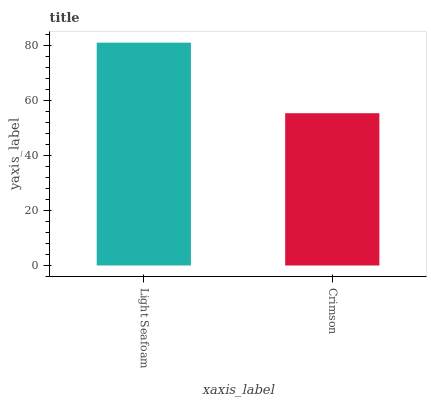Is Crimson the maximum?
Answer yes or no. No. Is Light Seafoam greater than Crimson?
Answer yes or no. Yes. Is Crimson less than Light Seafoam?
Answer yes or no. Yes. Is Crimson greater than Light Seafoam?
Answer yes or no. No. Is Light Seafoam less than Crimson?
Answer yes or no. No. Is Light Seafoam the high median?
Answer yes or no. Yes. Is Crimson the low median?
Answer yes or no. Yes. Is Crimson the high median?
Answer yes or no. No. Is Light Seafoam the low median?
Answer yes or no. No. 